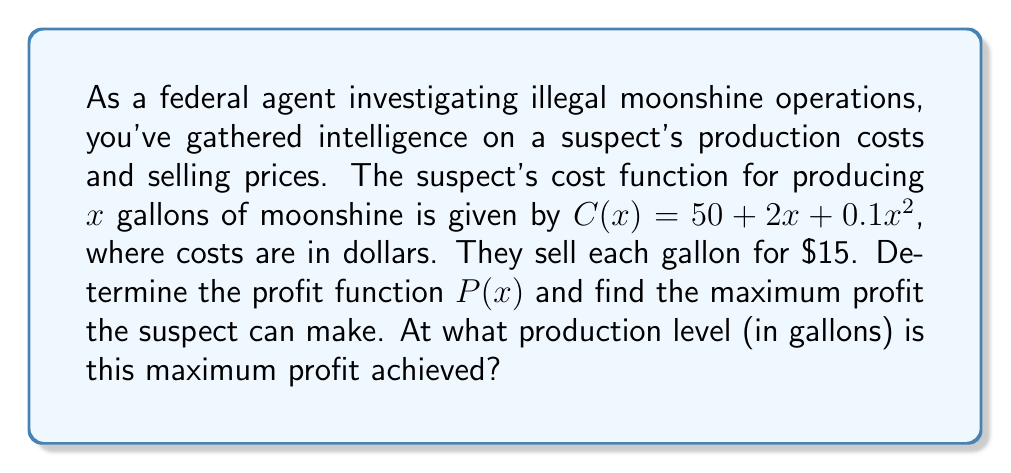Give your solution to this math problem. Let's approach this step-by-step:

1) First, we need to determine the revenue function. Revenue is price per unit multiplied by the number of units sold:
   $R(x) = 15x$

2) The profit function is revenue minus costs:
   $P(x) = R(x) - C(x)$
   $P(x) = 15x - (50 + 2x + 0.1x^2)$
   $P(x) = 15x - 50 - 2x - 0.1x^2$
   $P(x) = -0.1x^2 + 13x - 50$

3) To find the maximum profit, we need to find the vertex of this parabola. We can do this by finding where the derivative equals zero:
   $P'(x) = -0.2x + 13$
   Set $P'(x) = 0$:
   $-0.2x + 13 = 0$
   $-0.2x = -13$
   $x = 65$

4) To confirm this is a maximum (not a minimum), we can check that the second derivative is negative:
   $P''(x) = -0.2$, which is indeed negative.

5) The production level for maximum profit is 65 gallons.

6) To find the maximum profit, we substitute x = 65 into our profit function:
   $P(65) = -0.1(65)^2 + 13(65) - 50$
   $= -422.5 + 845 - 50$
   $= 372.5$

Therefore, the maximum profit is $\$372.50$.
Answer: The profit function is $P(x) = -0.1x^2 + 13x - 50$. The maximum profit is $\$372.50$, achieved at a production level of 65 gallons. 